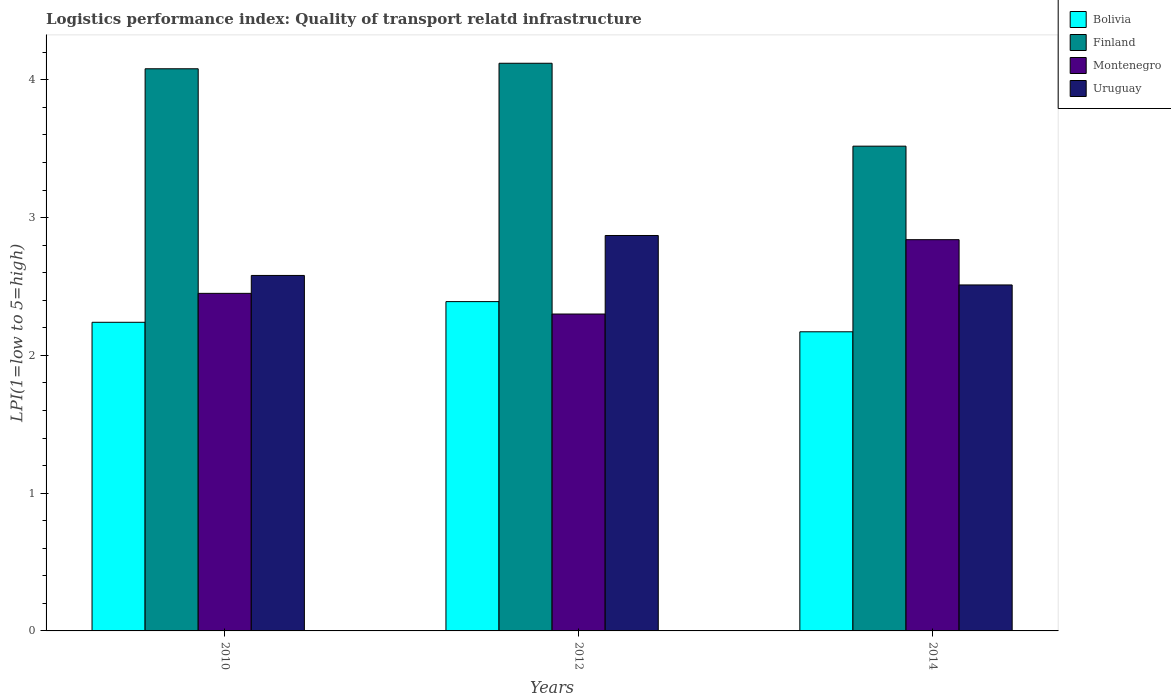How many groups of bars are there?
Provide a short and direct response. 3. Are the number of bars per tick equal to the number of legend labels?
Offer a very short reply. Yes. How many bars are there on the 3rd tick from the right?
Your answer should be compact. 4. What is the label of the 2nd group of bars from the left?
Give a very brief answer. 2012. In how many cases, is the number of bars for a given year not equal to the number of legend labels?
Keep it short and to the point. 0. What is the logistics performance index in Bolivia in 2014?
Offer a very short reply. 2.17. Across all years, what is the maximum logistics performance index in Bolivia?
Make the answer very short. 2.39. Across all years, what is the minimum logistics performance index in Uruguay?
Your response must be concise. 2.51. What is the total logistics performance index in Finland in the graph?
Ensure brevity in your answer.  11.72. What is the difference between the logistics performance index in Bolivia in 2010 and that in 2014?
Your answer should be compact. 0.07. What is the difference between the logistics performance index in Finland in 2010 and the logistics performance index in Bolivia in 2012?
Your response must be concise. 1.69. What is the average logistics performance index in Uruguay per year?
Make the answer very short. 2.65. In the year 2012, what is the difference between the logistics performance index in Bolivia and logistics performance index in Montenegro?
Your answer should be very brief. 0.09. What is the ratio of the logistics performance index in Montenegro in 2010 to that in 2012?
Provide a short and direct response. 1.07. What is the difference between the highest and the second highest logistics performance index in Montenegro?
Provide a short and direct response. 0.39. What is the difference between the highest and the lowest logistics performance index in Finland?
Offer a very short reply. 0.6. In how many years, is the logistics performance index in Bolivia greater than the average logistics performance index in Bolivia taken over all years?
Provide a succinct answer. 1. Is it the case that in every year, the sum of the logistics performance index in Uruguay and logistics performance index in Bolivia is greater than the sum of logistics performance index in Finland and logistics performance index in Montenegro?
Provide a short and direct response. No. Is it the case that in every year, the sum of the logistics performance index in Montenegro and logistics performance index in Finland is greater than the logistics performance index in Uruguay?
Your response must be concise. Yes. How many bars are there?
Provide a succinct answer. 12. Are all the bars in the graph horizontal?
Offer a terse response. No. How many years are there in the graph?
Give a very brief answer. 3. What is the difference between two consecutive major ticks on the Y-axis?
Provide a short and direct response. 1. Does the graph contain any zero values?
Your answer should be very brief. No. Does the graph contain grids?
Offer a terse response. No. Where does the legend appear in the graph?
Your answer should be very brief. Top right. How many legend labels are there?
Provide a succinct answer. 4. What is the title of the graph?
Provide a succinct answer. Logistics performance index: Quality of transport relatd infrastructure. Does "Mexico" appear as one of the legend labels in the graph?
Make the answer very short. No. What is the label or title of the X-axis?
Offer a terse response. Years. What is the label or title of the Y-axis?
Ensure brevity in your answer.  LPI(1=low to 5=high). What is the LPI(1=low to 5=high) of Bolivia in 2010?
Make the answer very short. 2.24. What is the LPI(1=low to 5=high) of Finland in 2010?
Your answer should be compact. 4.08. What is the LPI(1=low to 5=high) in Montenegro in 2010?
Provide a short and direct response. 2.45. What is the LPI(1=low to 5=high) of Uruguay in 2010?
Make the answer very short. 2.58. What is the LPI(1=low to 5=high) of Bolivia in 2012?
Offer a terse response. 2.39. What is the LPI(1=low to 5=high) in Finland in 2012?
Provide a short and direct response. 4.12. What is the LPI(1=low to 5=high) in Montenegro in 2012?
Offer a very short reply. 2.3. What is the LPI(1=low to 5=high) in Uruguay in 2012?
Give a very brief answer. 2.87. What is the LPI(1=low to 5=high) in Bolivia in 2014?
Your response must be concise. 2.17. What is the LPI(1=low to 5=high) of Finland in 2014?
Offer a very short reply. 3.52. What is the LPI(1=low to 5=high) of Montenegro in 2014?
Make the answer very short. 2.84. What is the LPI(1=low to 5=high) of Uruguay in 2014?
Make the answer very short. 2.51. Across all years, what is the maximum LPI(1=low to 5=high) in Bolivia?
Offer a terse response. 2.39. Across all years, what is the maximum LPI(1=low to 5=high) of Finland?
Give a very brief answer. 4.12. Across all years, what is the maximum LPI(1=low to 5=high) in Montenegro?
Give a very brief answer. 2.84. Across all years, what is the maximum LPI(1=low to 5=high) in Uruguay?
Make the answer very short. 2.87. Across all years, what is the minimum LPI(1=low to 5=high) of Bolivia?
Give a very brief answer. 2.17. Across all years, what is the minimum LPI(1=low to 5=high) of Finland?
Make the answer very short. 3.52. Across all years, what is the minimum LPI(1=low to 5=high) in Uruguay?
Ensure brevity in your answer.  2.51. What is the total LPI(1=low to 5=high) of Bolivia in the graph?
Offer a very short reply. 6.8. What is the total LPI(1=low to 5=high) in Finland in the graph?
Your response must be concise. 11.72. What is the total LPI(1=low to 5=high) in Montenegro in the graph?
Your response must be concise. 7.59. What is the total LPI(1=low to 5=high) of Uruguay in the graph?
Your answer should be compact. 7.96. What is the difference between the LPI(1=low to 5=high) of Bolivia in 2010 and that in 2012?
Your answer should be compact. -0.15. What is the difference between the LPI(1=low to 5=high) in Finland in 2010 and that in 2012?
Offer a terse response. -0.04. What is the difference between the LPI(1=low to 5=high) of Uruguay in 2010 and that in 2012?
Keep it short and to the point. -0.29. What is the difference between the LPI(1=low to 5=high) in Bolivia in 2010 and that in 2014?
Make the answer very short. 0.07. What is the difference between the LPI(1=low to 5=high) in Finland in 2010 and that in 2014?
Ensure brevity in your answer.  0.56. What is the difference between the LPI(1=low to 5=high) of Montenegro in 2010 and that in 2014?
Your response must be concise. -0.39. What is the difference between the LPI(1=low to 5=high) in Uruguay in 2010 and that in 2014?
Make the answer very short. 0.07. What is the difference between the LPI(1=low to 5=high) of Bolivia in 2012 and that in 2014?
Make the answer very short. 0.22. What is the difference between the LPI(1=low to 5=high) of Finland in 2012 and that in 2014?
Your answer should be compact. 0.6. What is the difference between the LPI(1=low to 5=high) in Montenegro in 2012 and that in 2014?
Keep it short and to the point. -0.54. What is the difference between the LPI(1=low to 5=high) in Uruguay in 2012 and that in 2014?
Ensure brevity in your answer.  0.36. What is the difference between the LPI(1=low to 5=high) in Bolivia in 2010 and the LPI(1=low to 5=high) in Finland in 2012?
Offer a terse response. -1.88. What is the difference between the LPI(1=low to 5=high) of Bolivia in 2010 and the LPI(1=low to 5=high) of Montenegro in 2012?
Offer a very short reply. -0.06. What is the difference between the LPI(1=low to 5=high) in Bolivia in 2010 and the LPI(1=low to 5=high) in Uruguay in 2012?
Offer a terse response. -0.63. What is the difference between the LPI(1=low to 5=high) in Finland in 2010 and the LPI(1=low to 5=high) in Montenegro in 2012?
Make the answer very short. 1.78. What is the difference between the LPI(1=low to 5=high) of Finland in 2010 and the LPI(1=low to 5=high) of Uruguay in 2012?
Your response must be concise. 1.21. What is the difference between the LPI(1=low to 5=high) in Montenegro in 2010 and the LPI(1=low to 5=high) in Uruguay in 2012?
Provide a short and direct response. -0.42. What is the difference between the LPI(1=low to 5=high) of Bolivia in 2010 and the LPI(1=low to 5=high) of Finland in 2014?
Provide a succinct answer. -1.28. What is the difference between the LPI(1=low to 5=high) of Bolivia in 2010 and the LPI(1=low to 5=high) of Montenegro in 2014?
Offer a terse response. -0.6. What is the difference between the LPI(1=low to 5=high) in Bolivia in 2010 and the LPI(1=low to 5=high) in Uruguay in 2014?
Your answer should be compact. -0.27. What is the difference between the LPI(1=low to 5=high) of Finland in 2010 and the LPI(1=low to 5=high) of Montenegro in 2014?
Offer a very short reply. 1.24. What is the difference between the LPI(1=low to 5=high) of Finland in 2010 and the LPI(1=low to 5=high) of Uruguay in 2014?
Your answer should be very brief. 1.57. What is the difference between the LPI(1=low to 5=high) in Montenegro in 2010 and the LPI(1=low to 5=high) in Uruguay in 2014?
Your response must be concise. -0.06. What is the difference between the LPI(1=low to 5=high) of Bolivia in 2012 and the LPI(1=low to 5=high) of Finland in 2014?
Offer a terse response. -1.13. What is the difference between the LPI(1=low to 5=high) in Bolivia in 2012 and the LPI(1=low to 5=high) in Montenegro in 2014?
Provide a short and direct response. -0.45. What is the difference between the LPI(1=low to 5=high) of Bolivia in 2012 and the LPI(1=low to 5=high) of Uruguay in 2014?
Give a very brief answer. -0.12. What is the difference between the LPI(1=low to 5=high) of Finland in 2012 and the LPI(1=low to 5=high) of Montenegro in 2014?
Give a very brief answer. 1.28. What is the difference between the LPI(1=low to 5=high) of Finland in 2012 and the LPI(1=low to 5=high) of Uruguay in 2014?
Your response must be concise. 1.61. What is the difference between the LPI(1=low to 5=high) of Montenegro in 2012 and the LPI(1=low to 5=high) of Uruguay in 2014?
Offer a very short reply. -0.21. What is the average LPI(1=low to 5=high) of Bolivia per year?
Offer a terse response. 2.27. What is the average LPI(1=low to 5=high) of Finland per year?
Keep it short and to the point. 3.91. What is the average LPI(1=low to 5=high) of Montenegro per year?
Provide a succinct answer. 2.53. What is the average LPI(1=low to 5=high) in Uruguay per year?
Your answer should be very brief. 2.65. In the year 2010, what is the difference between the LPI(1=low to 5=high) in Bolivia and LPI(1=low to 5=high) in Finland?
Your response must be concise. -1.84. In the year 2010, what is the difference between the LPI(1=low to 5=high) in Bolivia and LPI(1=low to 5=high) in Montenegro?
Make the answer very short. -0.21. In the year 2010, what is the difference between the LPI(1=low to 5=high) in Bolivia and LPI(1=low to 5=high) in Uruguay?
Make the answer very short. -0.34. In the year 2010, what is the difference between the LPI(1=low to 5=high) in Finland and LPI(1=low to 5=high) in Montenegro?
Offer a very short reply. 1.63. In the year 2010, what is the difference between the LPI(1=low to 5=high) in Montenegro and LPI(1=low to 5=high) in Uruguay?
Your response must be concise. -0.13. In the year 2012, what is the difference between the LPI(1=low to 5=high) in Bolivia and LPI(1=low to 5=high) in Finland?
Provide a succinct answer. -1.73. In the year 2012, what is the difference between the LPI(1=low to 5=high) of Bolivia and LPI(1=low to 5=high) of Montenegro?
Ensure brevity in your answer.  0.09. In the year 2012, what is the difference between the LPI(1=low to 5=high) in Bolivia and LPI(1=low to 5=high) in Uruguay?
Give a very brief answer. -0.48. In the year 2012, what is the difference between the LPI(1=low to 5=high) in Finland and LPI(1=low to 5=high) in Montenegro?
Offer a terse response. 1.82. In the year 2012, what is the difference between the LPI(1=low to 5=high) in Finland and LPI(1=low to 5=high) in Uruguay?
Ensure brevity in your answer.  1.25. In the year 2012, what is the difference between the LPI(1=low to 5=high) of Montenegro and LPI(1=low to 5=high) of Uruguay?
Your answer should be compact. -0.57. In the year 2014, what is the difference between the LPI(1=low to 5=high) in Bolivia and LPI(1=low to 5=high) in Finland?
Your answer should be compact. -1.35. In the year 2014, what is the difference between the LPI(1=low to 5=high) in Bolivia and LPI(1=low to 5=high) in Montenegro?
Ensure brevity in your answer.  -0.67. In the year 2014, what is the difference between the LPI(1=low to 5=high) in Bolivia and LPI(1=low to 5=high) in Uruguay?
Ensure brevity in your answer.  -0.34. In the year 2014, what is the difference between the LPI(1=low to 5=high) in Finland and LPI(1=low to 5=high) in Montenegro?
Offer a terse response. 0.68. In the year 2014, what is the difference between the LPI(1=low to 5=high) in Montenegro and LPI(1=low to 5=high) in Uruguay?
Give a very brief answer. 0.33. What is the ratio of the LPI(1=low to 5=high) in Bolivia in 2010 to that in 2012?
Give a very brief answer. 0.94. What is the ratio of the LPI(1=low to 5=high) in Finland in 2010 to that in 2012?
Your answer should be compact. 0.99. What is the ratio of the LPI(1=low to 5=high) of Montenegro in 2010 to that in 2012?
Make the answer very short. 1.07. What is the ratio of the LPI(1=low to 5=high) of Uruguay in 2010 to that in 2012?
Your answer should be compact. 0.9. What is the ratio of the LPI(1=low to 5=high) in Bolivia in 2010 to that in 2014?
Provide a succinct answer. 1.03. What is the ratio of the LPI(1=low to 5=high) of Finland in 2010 to that in 2014?
Make the answer very short. 1.16. What is the ratio of the LPI(1=low to 5=high) of Montenegro in 2010 to that in 2014?
Ensure brevity in your answer.  0.86. What is the ratio of the LPI(1=low to 5=high) of Uruguay in 2010 to that in 2014?
Provide a short and direct response. 1.03. What is the ratio of the LPI(1=low to 5=high) in Bolivia in 2012 to that in 2014?
Your response must be concise. 1.1. What is the ratio of the LPI(1=low to 5=high) in Finland in 2012 to that in 2014?
Give a very brief answer. 1.17. What is the ratio of the LPI(1=low to 5=high) of Montenegro in 2012 to that in 2014?
Give a very brief answer. 0.81. What is the ratio of the LPI(1=low to 5=high) in Uruguay in 2012 to that in 2014?
Your answer should be very brief. 1.14. What is the difference between the highest and the second highest LPI(1=low to 5=high) of Montenegro?
Provide a succinct answer. 0.39. What is the difference between the highest and the second highest LPI(1=low to 5=high) of Uruguay?
Keep it short and to the point. 0.29. What is the difference between the highest and the lowest LPI(1=low to 5=high) of Bolivia?
Provide a short and direct response. 0.22. What is the difference between the highest and the lowest LPI(1=low to 5=high) of Finland?
Keep it short and to the point. 0.6. What is the difference between the highest and the lowest LPI(1=low to 5=high) of Montenegro?
Your answer should be compact. 0.54. What is the difference between the highest and the lowest LPI(1=low to 5=high) in Uruguay?
Provide a short and direct response. 0.36. 